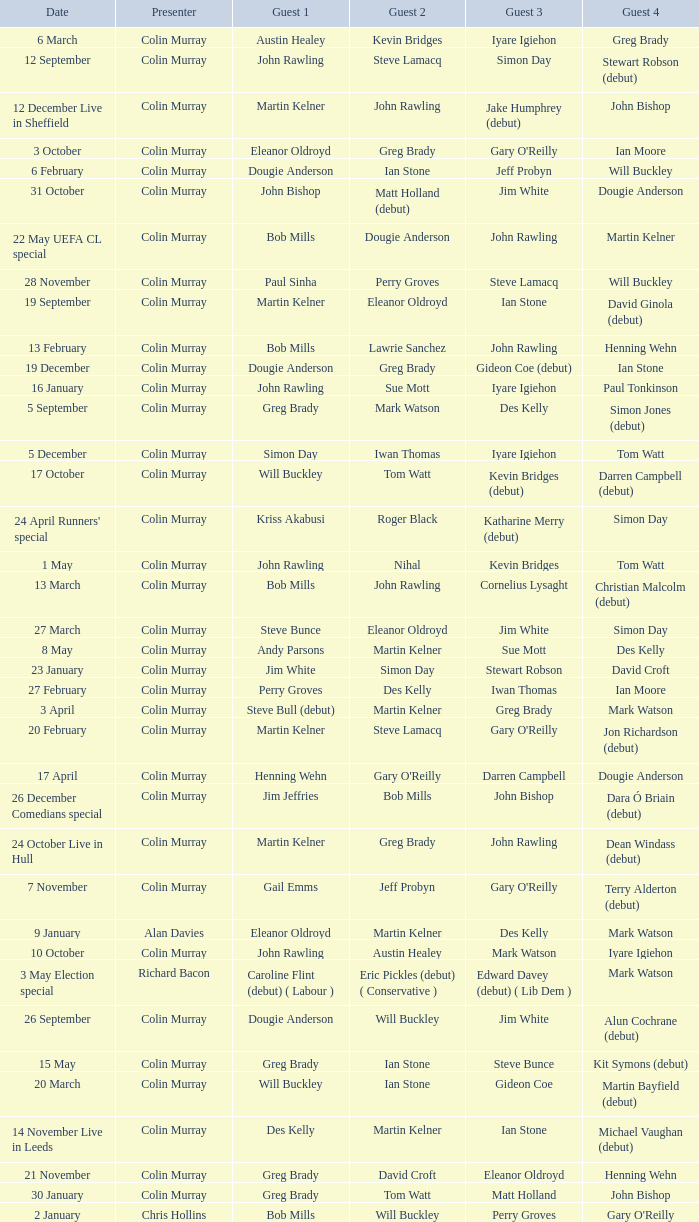Parse the table in full. {'header': ['Date', 'Presenter', 'Guest 1', 'Guest 2', 'Guest 3', 'Guest 4'], 'rows': [['6 March', 'Colin Murray', 'Austin Healey', 'Kevin Bridges', 'Iyare Igiehon', 'Greg Brady'], ['12 September', 'Colin Murray', 'John Rawling', 'Steve Lamacq', 'Simon Day', 'Stewart Robson (debut)'], ['12 December Live in Sheffield', 'Colin Murray', 'Martin Kelner', 'John Rawling', 'Jake Humphrey (debut)', 'John Bishop'], ['3 October', 'Colin Murray', 'Eleanor Oldroyd', 'Greg Brady', "Gary O'Reilly", 'Ian Moore'], ['6 February', 'Colin Murray', 'Dougie Anderson', 'Ian Stone', 'Jeff Probyn', 'Will Buckley'], ['31 October', 'Colin Murray', 'John Bishop', 'Matt Holland (debut)', 'Jim White', 'Dougie Anderson'], ['22 May UEFA CL special', 'Colin Murray', 'Bob Mills', 'Dougie Anderson', 'John Rawling', 'Martin Kelner'], ['28 November', 'Colin Murray', 'Paul Sinha', 'Perry Groves', 'Steve Lamacq', 'Will Buckley'], ['19 September', 'Colin Murray', 'Martin Kelner', 'Eleanor Oldroyd', 'Ian Stone', 'David Ginola (debut)'], ['13 February', 'Colin Murray', 'Bob Mills', 'Lawrie Sanchez', 'John Rawling', 'Henning Wehn'], ['19 December', 'Colin Murray', 'Dougie Anderson', 'Greg Brady', 'Gideon Coe (debut)', 'Ian Stone'], ['16 January', 'Colin Murray', 'John Rawling', 'Sue Mott', 'Iyare Igiehon', 'Paul Tonkinson'], ['5 September', 'Colin Murray', 'Greg Brady', 'Mark Watson', 'Des Kelly', 'Simon Jones (debut)'], ['5 December', 'Colin Murray', 'Simon Day', 'Iwan Thomas', 'Iyare Igiehon', 'Tom Watt'], ['17 October', 'Colin Murray', 'Will Buckley', 'Tom Watt', 'Kevin Bridges (debut)', 'Darren Campbell (debut)'], ["24 April Runners' special", 'Colin Murray', 'Kriss Akabusi', 'Roger Black', 'Katharine Merry (debut)', 'Simon Day'], ['1 May', 'Colin Murray', 'John Rawling', 'Nihal', 'Kevin Bridges', 'Tom Watt'], ['13 March', 'Colin Murray', 'Bob Mills', 'John Rawling', 'Cornelius Lysaght', 'Christian Malcolm (debut)'], ['27 March', 'Colin Murray', 'Steve Bunce', 'Eleanor Oldroyd', 'Jim White', 'Simon Day'], ['8 May', 'Colin Murray', 'Andy Parsons', 'Martin Kelner', 'Sue Mott', 'Des Kelly'], ['23 January', 'Colin Murray', 'Jim White', 'Simon Day', 'Stewart Robson', 'David Croft'], ['27 February', 'Colin Murray', 'Perry Groves', 'Des Kelly', 'Iwan Thomas', 'Ian Moore'], ['3 April', 'Colin Murray', 'Steve Bull (debut)', 'Martin Kelner', 'Greg Brady', 'Mark Watson'], ['20 February', 'Colin Murray', 'Martin Kelner', 'Steve Lamacq', "Gary O'Reilly", 'Jon Richardson (debut)'], ['17 April', 'Colin Murray', 'Henning Wehn', "Gary O'Reilly", 'Darren Campbell', 'Dougie Anderson'], ['26 December Comedians special', 'Colin Murray', 'Jim Jeffries', 'Bob Mills', 'John Bishop', 'Dara Ó Briain (debut)'], ['24 October Live in Hull', 'Colin Murray', 'Martin Kelner', 'Greg Brady', 'John Rawling', 'Dean Windass (debut)'], ['7 November', 'Colin Murray', 'Gail Emms', 'Jeff Probyn', "Gary O'Reilly", 'Terry Alderton (debut)'], ['9 January', 'Alan Davies', 'Eleanor Oldroyd', 'Martin Kelner', 'Des Kelly', 'Mark Watson'], ['10 October', 'Colin Murray', 'John Rawling', 'Austin Healey', 'Mark Watson', 'Iyare Igiehon'], ['3 May Election special', 'Richard Bacon', 'Caroline Flint (debut) ( Labour )', 'Eric Pickles (debut) ( Conservative )', 'Edward Davey (debut) ( Lib Dem )', 'Mark Watson'], ['26 September', 'Colin Murray', 'Dougie Anderson', 'Will Buckley', 'Jim White', 'Alun Cochrane (debut)'], ['15 May', 'Colin Murray', 'Greg Brady', 'Ian Stone', 'Steve Bunce', 'Kit Symons (debut)'], ['20 March', 'Colin Murray', 'Will Buckley', 'Ian Stone', 'Gideon Coe', 'Martin Bayfield (debut)'], ['14 November Live in Leeds', 'Colin Murray', 'Des Kelly', 'Martin Kelner', 'Ian Stone', 'Michael Vaughan (debut)'], ['21 November', 'Colin Murray', 'Greg Brady', 'David Croft', 'Eleanor Oldroyd', 'Henning Wehn'], ['30 January', 'Colin Murray', 'Greg Brady', 'Tom Watt', 'Matt Holland', 'John Bishop'], ['2 January', 'Chris Hollins', 'Bob Mills', 'Will Buckley', 'Perry Groves', "Gary O'Reilly"]]} How many people are guest 1 on episodes where guest 4 is Des Kelly? 1.0. 